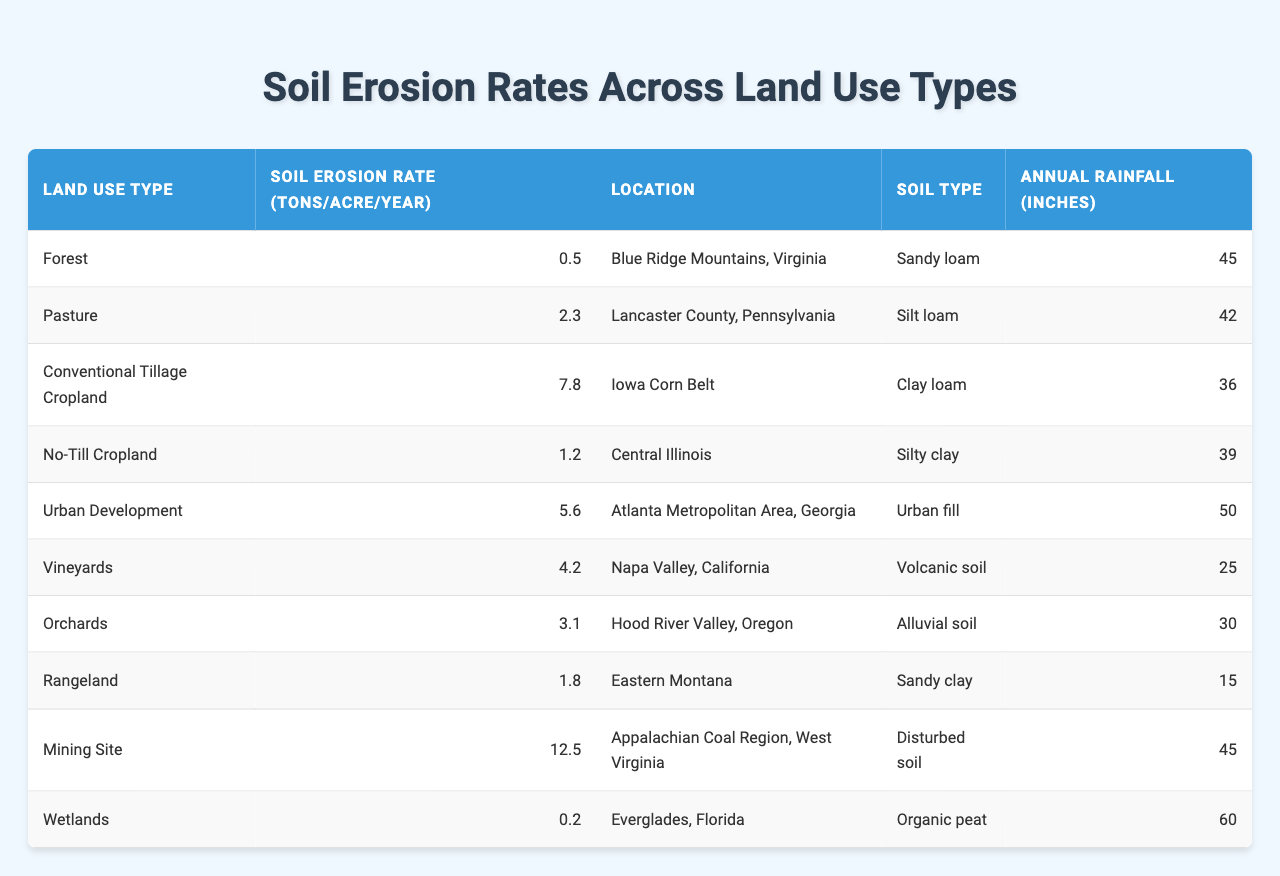What is the soil erosion rate for Urban Development? The table lists the soil erosion rates by land use type. For Urban Development, the associated erosion rate is 5.6 tons/acre/year.
Answer: 5.6 Which land use type has the highest soil erosion rate? By examining the table, the highest erosion rate is for Mining Site, which shows 12.5 tons/acre/year.
Answer: Mining Site What is the average soil erosion rate of all land use types listed? To find the average, we sum all the erosion rates: (0.5 + 2.3 + 7.8 + 1.2 + 5.6 + 4.2 + 3.1 + 1.8 + 12.5 + 0.2) = 39.8. There are 10 land use types, so the average is 39.8 / 10 = 3.98.
Answer: 3.98 Is the soil erosion rate for Rangeland greater than Urban Development? Checking the rates, Rangeland has an erosion rate of 1.8 tons/acre/year, while Urban Development has 5.6 tons/acre/year. Therefore, Rangeland's rate is not greater.
Answer: No Which soil type is associated with the highest erosion rate? Referencing the table, the highest erosion rate (12.5 tons/acre/year) corresponds to the Mining Site, which has disturbed soil.
Answer: Disturbed soil What is the total erosion rate from Cropland (Conventional Tillage and No-Till)? The total erosion rate for Cropland is calculated by adding both rates: Conventional Tillage (7.8) + No-Till (1.2) = 9.0 tons/acre/year.
Answer: 9.0 Which land use type has the lowest erosion rate among those listed? The table indicates that Wetlands have the lowest soil erosion rate at 0.2 tons/acre/year.
Answer: Wetlands How does the soil erosion rate for Vineyards compare to Orchards? Vineyards have a soil erosion rate of 4.2 tons/acre/year, while Orchards have 3.1 tons/acre/year. Since 4.2 is greater than 3.1, Vineyards have a higher rate.
Answer: Vineyards have a higher rate How much more erosion occurs in Conventional Tillage Cropland compared to No-Till Cropland? The erosion rate for Conventional Tillage Cropland is 7.8 tons/acre/year, and for No-Till Cropland it is 1.2 tons/acre/year. The difference is 7.8 - 1.2 = 6.6 tons/acre/year.
Answer: 6.6 Which region has the highest annual rainfall, and what is its soil erosion rate? The table shows that the region with the highest annual rainfall is Wetlands at 60 inches, and their soil erosion rate is 0.2 tons/acre/year.
Answer: 0.2 tons/acre/year in Wetlands 